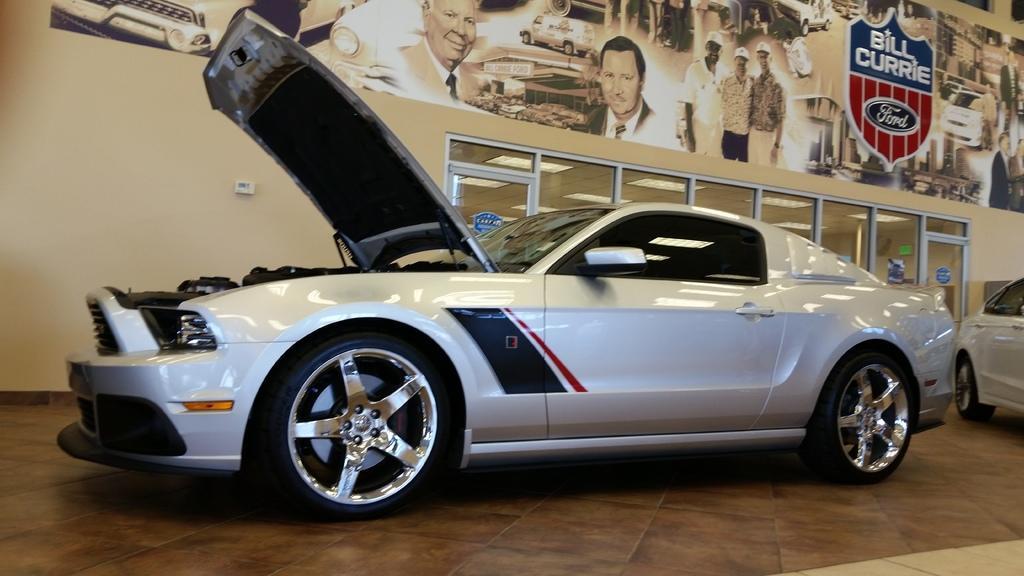Could you give a brief overview of what you see in this image? In this image, we can see vehicles on the floor and in the background, there is a poster and we can see glass doors and a wall. 